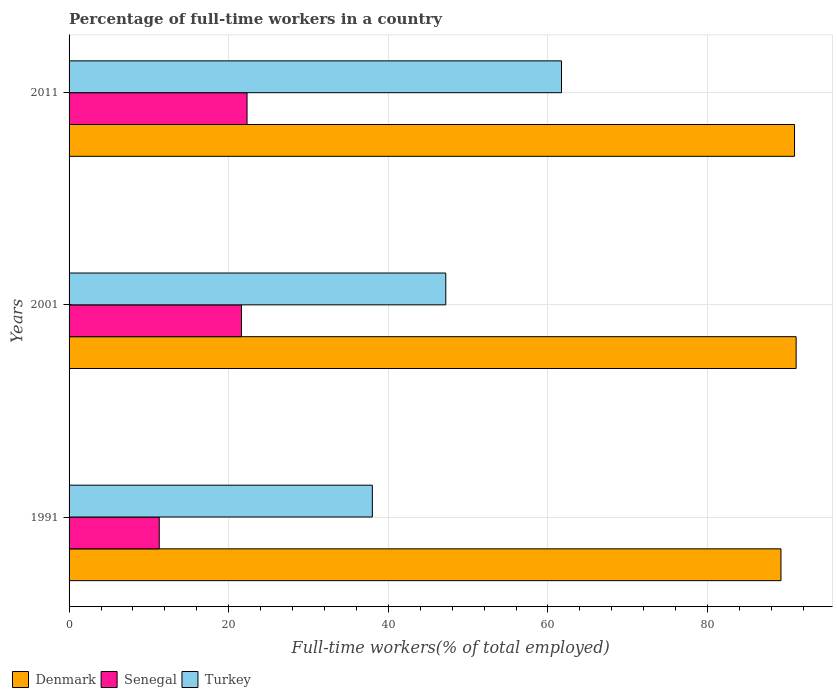What is the label of the 1st group of bars from the top?
Offer a very short reply. 2011. What is the percentage of full-time workers in Denmark in 1991?
Provide a succinct answer. 89.2. Across all years, what is the maximum percentage of full-time workers in Turkey?
Offer a terse response. 61.7. Across all years, what is the minimum percentage of full-time workers in Senegal?
Your answer should be compact. 11.3. In which year was the percentage of full-time workers in Denmark maximum?
Offer a very short reply. 2001. What is the total percentage of full-time workers in Turkey in the graph?
Offer a terse response. 146.9. What is the difference between the percentage of full-time workers in Turkey in 1991 and that in 2011?
Give a very brief answer. -23.7. What is the difference between the percentage of full-time workers in Senegal in 2011 and the percentage of full-time workers in Turkey in 2001?
Make the answer very short. -24.9. What is the average percentage of full-time workers in Turkey per year?
Offer a terse response. 48.97. In the year 2001, what is the difference between the percentage of full-time workers in Denmark and percentage of full-time workers in Senegal?
Your answer should be compact. 69.5. In how many years, is the percentage of full-time workers in Senegal greater than 44 %?
Provide a short and direct response. 0. What is the ratio of the percentage of full-time workers in Turkey in 1991 to that in 2001?
Give a very brief answer. 0.81. Is the percentage of full-time workers in Senegal in 2001 less than that in 2011?
Offer a very short reply. Yes. Is the difference between the percentage of full-time workers in Denmark in 1991 and 2011 greater than the difference between the percentage of full-time workers in Senegal in 1991 and 2011?
Your answer should be compact. Yes. What is the difference between the highest and the second highest percentage of full-time workers in Senegal?
Your response must be concise. 0.7. What is the difference between the highest and the lowest percentage of full-time workers in Denmark?
Make the answer very short. 1.9. In how many years, is the percentage of full-time workers in Senegal greater than the average percentage of full-time workers in Senegal taken over all years?
Provide a succinct answer. 2. What does the 2nd bar from the top in 2011 represents?
Offer a terse response. Senegal. How many years are there in the graph?
Keep it short and to the point. 3. What is the difference between two consecutive major ticks on the X-axis?
Ensure brevity in your answer.  20. Are the values on the major ticks of X-axis written in scientific E-notation?
Offer a terse response. No. Does the graph contain any zero values?
Offer a terse response. No. Where does the legend appear in the graph?
Provide a short and direct response. Bottom left. How many legend labels are there?
Offer a terse response. 3. What is the title of the graph?
Keep it short and to the point. Percentage of full-time workers in a country. What is the label or title of the X-axis?
Keep it short and to the point. Full-time workers(% of total employed). What is the Full-time workers(% of total employed) in Denmark in 1991?
Your response must be concise. 89.2. What is the Full-time workers(% of total employed) in Senegal in 1991?
Keep it short and to the point. 11.3. What is the Full-time workers(% of total employed) of Denmark in 2001?
Give a very brief answer. 91.1. What is the Full-time workers(% of total employed) of Senegal in 2001?
Your answer should be very brief. 21.6. What is the Full-time workers(% of total employed) of Turkey in 2001?
Your answer should be compact. 47.2. What is the Full-time workers(% of total employed) in Denmark in 2011?
Offer a terse response. 90.9. What is the Full-time workers(% of total employed) in Senegal in 2011?
Provide a succinct answer. 22.3. What is the Full-time workers(% of total employed) of Turkey in 2011?
Your answer should be compact. 61.7. Across all years, what is the maximum Full-time workers(% of total employed) of Denmark?
Your answer should be compact. 91.1. Across all years, what is the maximum Full-time workers(% of total employed) of Senegal?
Provide a succinct answer. 22.3. Across all years, what is the maximum Full-time workers(% of total employed) of Turkey?
Your response must be concise. 61.7. Across all years, what is the minimum Full-time workers(% of total employed) in Denmark?
Your response must be concise. 89.2. Across all years, what is the minimum Full-time workers(% of total employed) in Senegal?
Your answer should be very brief. 11.3. Across all years, what is the minimum Full-time workers(% of total employed) of Turkey?
Keep it short and to the point. 38. What is the total Full-time workers(% of total employed) of Denmark in the graph?
Offer a terse response. 271.2. What is the total Full-time workers(% of total employed) of Senegal in the graph?
Give a very brief answer. 55.2. What is the total Full-time workers(% of total employed) of Turkey in the graph?
Your answer should be compact. 146.9. What is the difference between the Full-time workers(% of total employed) of Denmark in 1991 and that in 2001?
Keep it short and to the point. -1.9. What is the difference between the Full-time workers(% of total employed) in Senegal in 1991 and that in 2001?
Your response must be concise. -10.3. What is the difference between the Full-time workers(% of total employed) in Turkey in 1991 and that in 2001?
Your response must be concise. -9.2. What is the difference between the Full-time workers(% of total employed) of Senegal in 1991 and that in 2011?
Ensure brevity in your answer.  -11. What is the difference between the Full-time workers(% of total employed) in Turkey in 1991 and that in 2011?
Provide a short and direct response. -23.7. What is the difference between the Full-time workers(% of total employed) of Senegal in 2001 and that in 2011?
Offer a terse response. -0.7. What is the difference between the Full-time workers(% of total employed) of Turkey in 2001 and that in 2011?
Your response must be concise. -14.5. What is the difference between the Full-time workers(% of total employed) of Denmark in 1991 and the Full-time workers(% of total employed) of Senegal in 2001?
Keep it short and to the point. 67.6. What is the difference between the Full-time workers(% of total employed) of Denmark in 1991 and the Full-time workers(% of total employed) of Turkey in 2001?
Provide a succinct answer. 42. What is the difference between the Full-time workers(% of total employed) of Senegal in 1991 and the Full-time workers(% of total employed) of Turkey in 2001?
Give a very brief answer. -35.9. What is the difference between the Full-time workers(% of total employed) of Denmark in 1991 and the Full-time workers(% of total employed) of Senegal in 2011?
Your response must be concise. 66.9. What is the difference between the Full-time workers(% of total employed) of Senegal in 1991 and the Full-time workers(% of total employed) of Turkey in 2011?
Offer a very short reply. -50.4. What is the difference between the Full-time workers(% of total employed) in Denmark in 2001 and the Full-time workers(% of total employed) in Senegal in 2011?
Your answer should be compact. 68.8. What is the difference between the Full-time workers(% of total employed) of Denmark in 2001 and the Full-time workers(% of total employed) of Turkey in 2011?
Provide a succinct answer. 29.4. What is the difference between the Full-time workers(% of total employed) in Senegal in 2001 and the Full-time workers(% of total employed) in Turkey in 2011?
Offer a terse response. -40.1. What is the average Full-time workers(% of total employed) of Denmark per year?
Your answer should be compact. 90.4. What is the average Full-time workers(% of total employed) in Senegal per year?
Offer a terse response. 18.4. What is the average Full-time workers(% of total employed) of Turkey per year?
Make the answer very short. 48.97. In the year 1991, what is the difference between the Full-time workers(% of total employed) of Denmark and Full-time workers(% of total employed) of Senegal?
Provide a short and direct response. 77.9. In the year 1991, what is the difference between the Full-time workers(% of total employed) of Denmark and Full-time workers(% of total employed) of Turkey?
Your response must be concise. 51.2. In the year 1991, what is the difference between the Full-time workers(% of total employed) of Senegal and Full-time workers(% of total employed) of Turkey?
Make the answer very short. -26.7. In the year 2001, what is the difference between the Full-time workers(% of total employed) of Denmark and Full-time workers(% of total employed) of Senegal?
Ensure brevity in your answer.  69.5. In the year 2001, what is the difference between the Full-time workers(% of total employed) of Denmark and Full-time workers(% of total employed) of Turkey?
Provide a succinct answer. 43.9. In the year 2001, what is the difference between the Full-time workers(% of total employed) of Senegal and Full-time workers(% of total employed) of Turkey?
Provide a succinct answer. -25.6. In the year 2011, what is the difference between the Full-time workers(% of total employed) in Denmark and Full-time workers(% of total employed) in Senegal?
Offer a very short reply. 68.6. In the year 2011, what is the difference between the Full-time workers(% of total employed) in Denmark and Full-time workers(% of total employed) in Turkey?
Make the answer very short. 29.2. In the year 2011, what is the difference between the Full-time workers(% of total employed) of Senegal and Full-time workers(% of total employed) of Turkey?
Your answer should be very brief. -39.4. What is the ratio of the Full-time workers(% of total employed) of Denmark in 1991 to that in 2001?
Ensure brevity in your answer.  0.98. What is the ratio of the Full-time workers(% of total employed) in Senegal in 1991 to that in 2001?
Provide a short and direct response. 0.52. What is the ratio of the Full-time workers(% of total employed) in Turkey in 1991 to that in 2001?
Your response must be concise. 0.81. What is the ratio of the Full-time workers(% of total employed) in Denmark in 1991 to that in 2011?
Offer a terse response. 0.98. What is the ratio of the Full-time workers(% of total employed) in Senegal in 1991 to that in 2011?
Provide a short and direct response. 0.51. What is the ratio of the Full-time workers(% of total employed) in Turkey in 1991 to that in 2011?
Your answer should be compact. 0.62. What is the ratio of the Full-time workers(% of total employed) of Denmark in 2001 to that in 2011?
Provide a short and direct response. 1. What is the ratio of the Full-time workers(% of total employed) in Senegal in 2001 to that in 2011?
Make the answer very short. 0.97. What is the ratio of the Full-time workers(% of total employed) of Turkey in 2001 to that in 2011?
Your answer should be very brief. 0.77. What is the difference between the highest and the second highest Full-time workers(% of total employed) of Turkey?
Provide a succinct answer. 14.5. What is the difference between the highest and the lowest Full-time workers(% of total employed) in Senegal?
Give a very brief answer. 11. What is the difference between the highest and the lowest Full-time workers(% of total employed) in Turkey?
Your answer should be very brief. 23.7. 